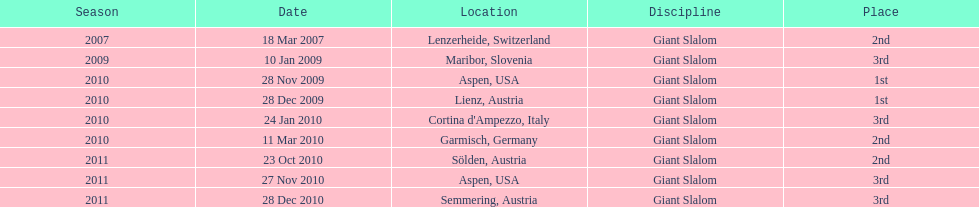What is the total number of her 2nd place finishes on the list? 3. 